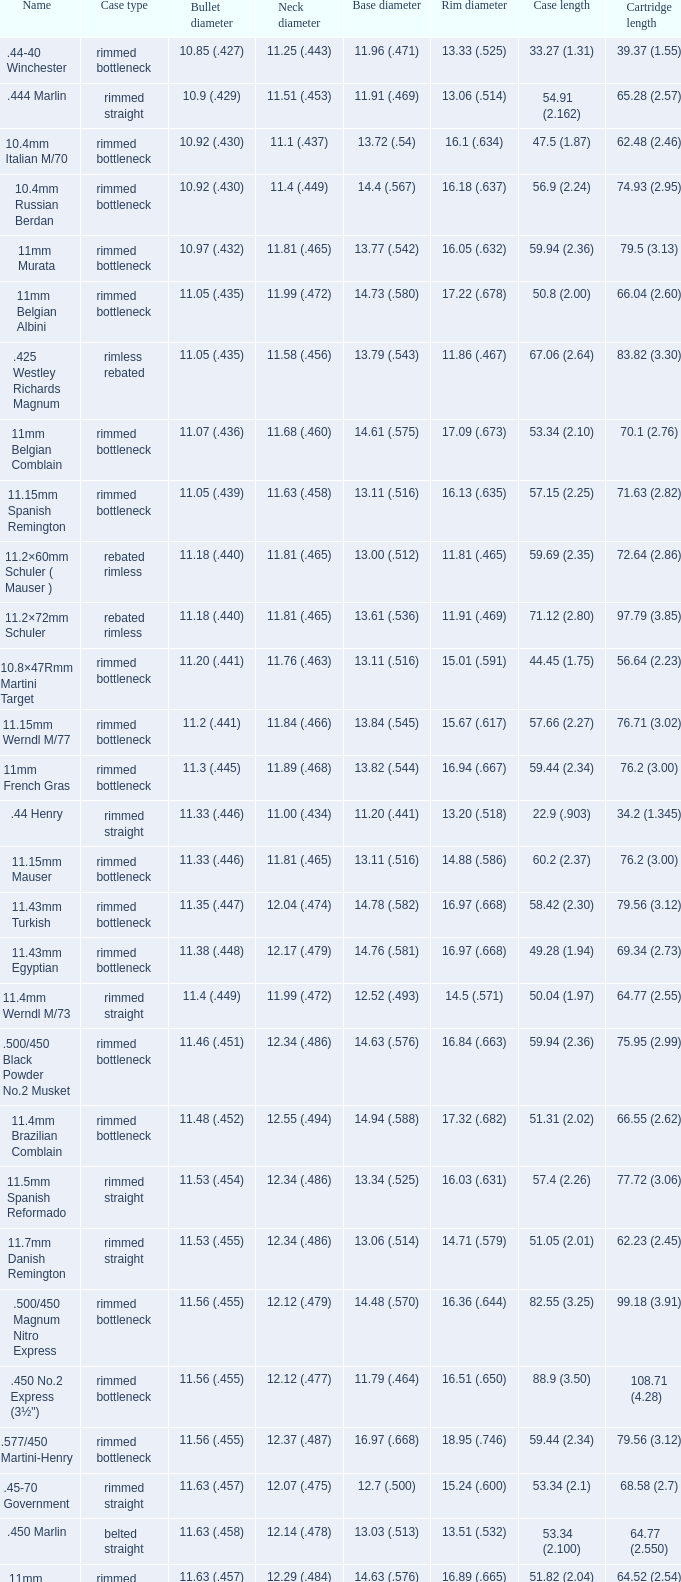Which Case type has a Base diameter of 13.03 (.513), and a Case length of 63.5 (2.5)? Belted straight. 